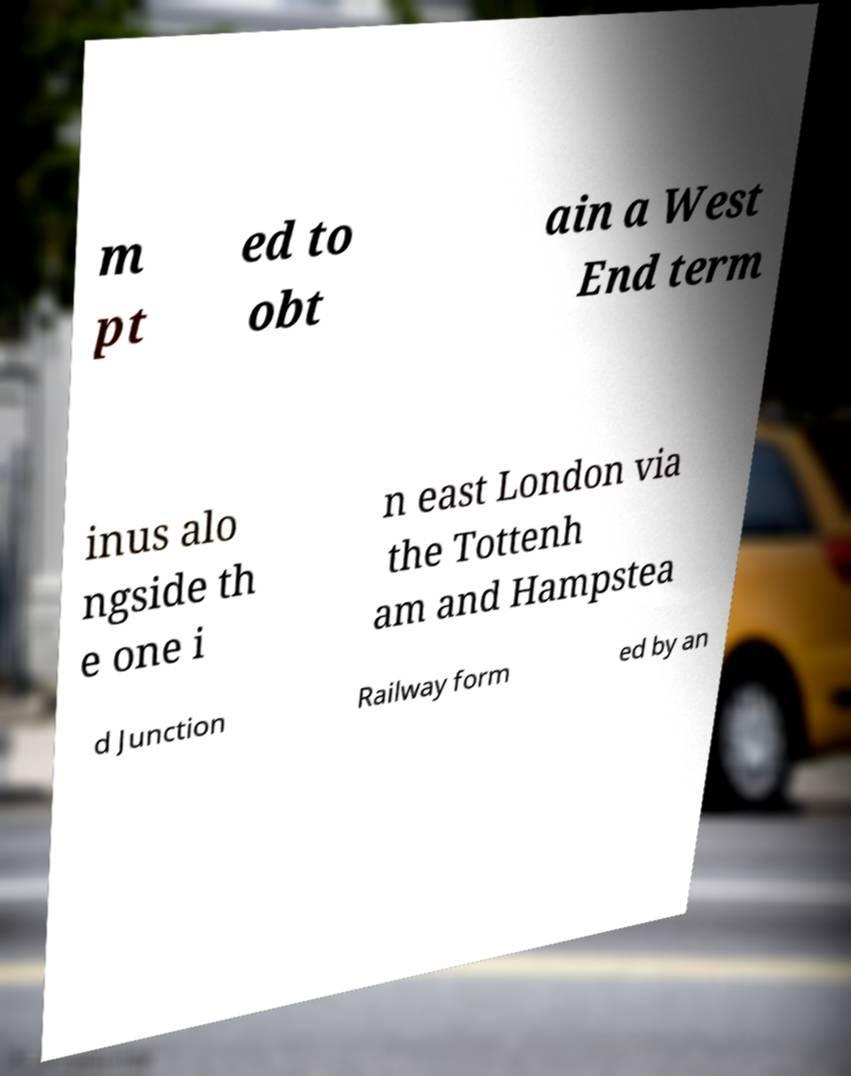Please read and relay the text visible in this image. What does it say? m pt ed to obt ain a West End term inus alo ngside th e one i n east London via the Tottenh am and Hampstea d Junction Railway form ed by an 